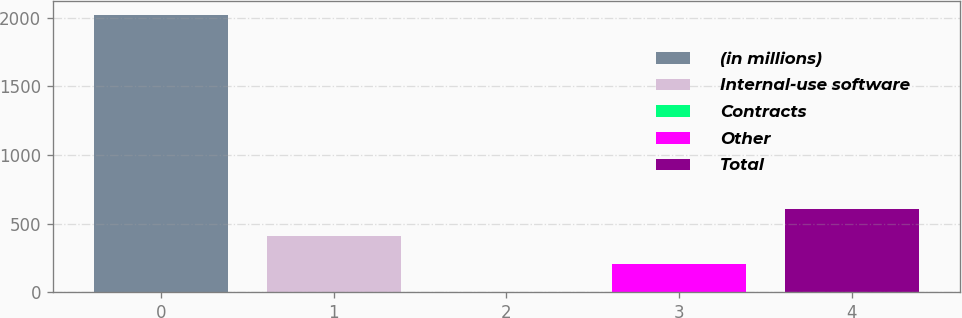<chart> <loc_0><loc_0><loc_500><loc_500><bar_chart><fcel>(in millions)<fcel>Internal-use software<fcel>Contracts<fcel>Other<fcel>Total<nl><fcel>2021<fcel>408.2<fcel>5<fcel>206.6<fcel>609.8<nl></chart> 